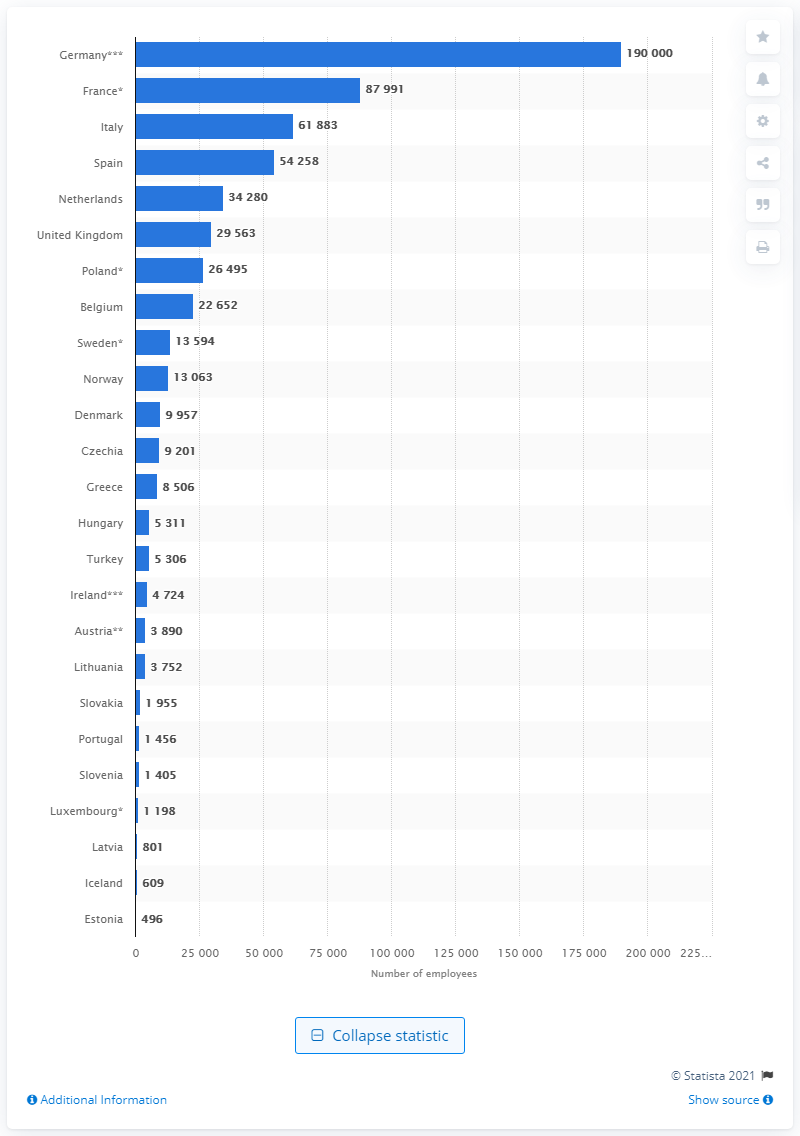Point out several critical features in this image. In 2018, there were 61,883 physiotherapists employed in Italy. In 2018, an estimated 190,000 physiotherapists were employed in Germany. 